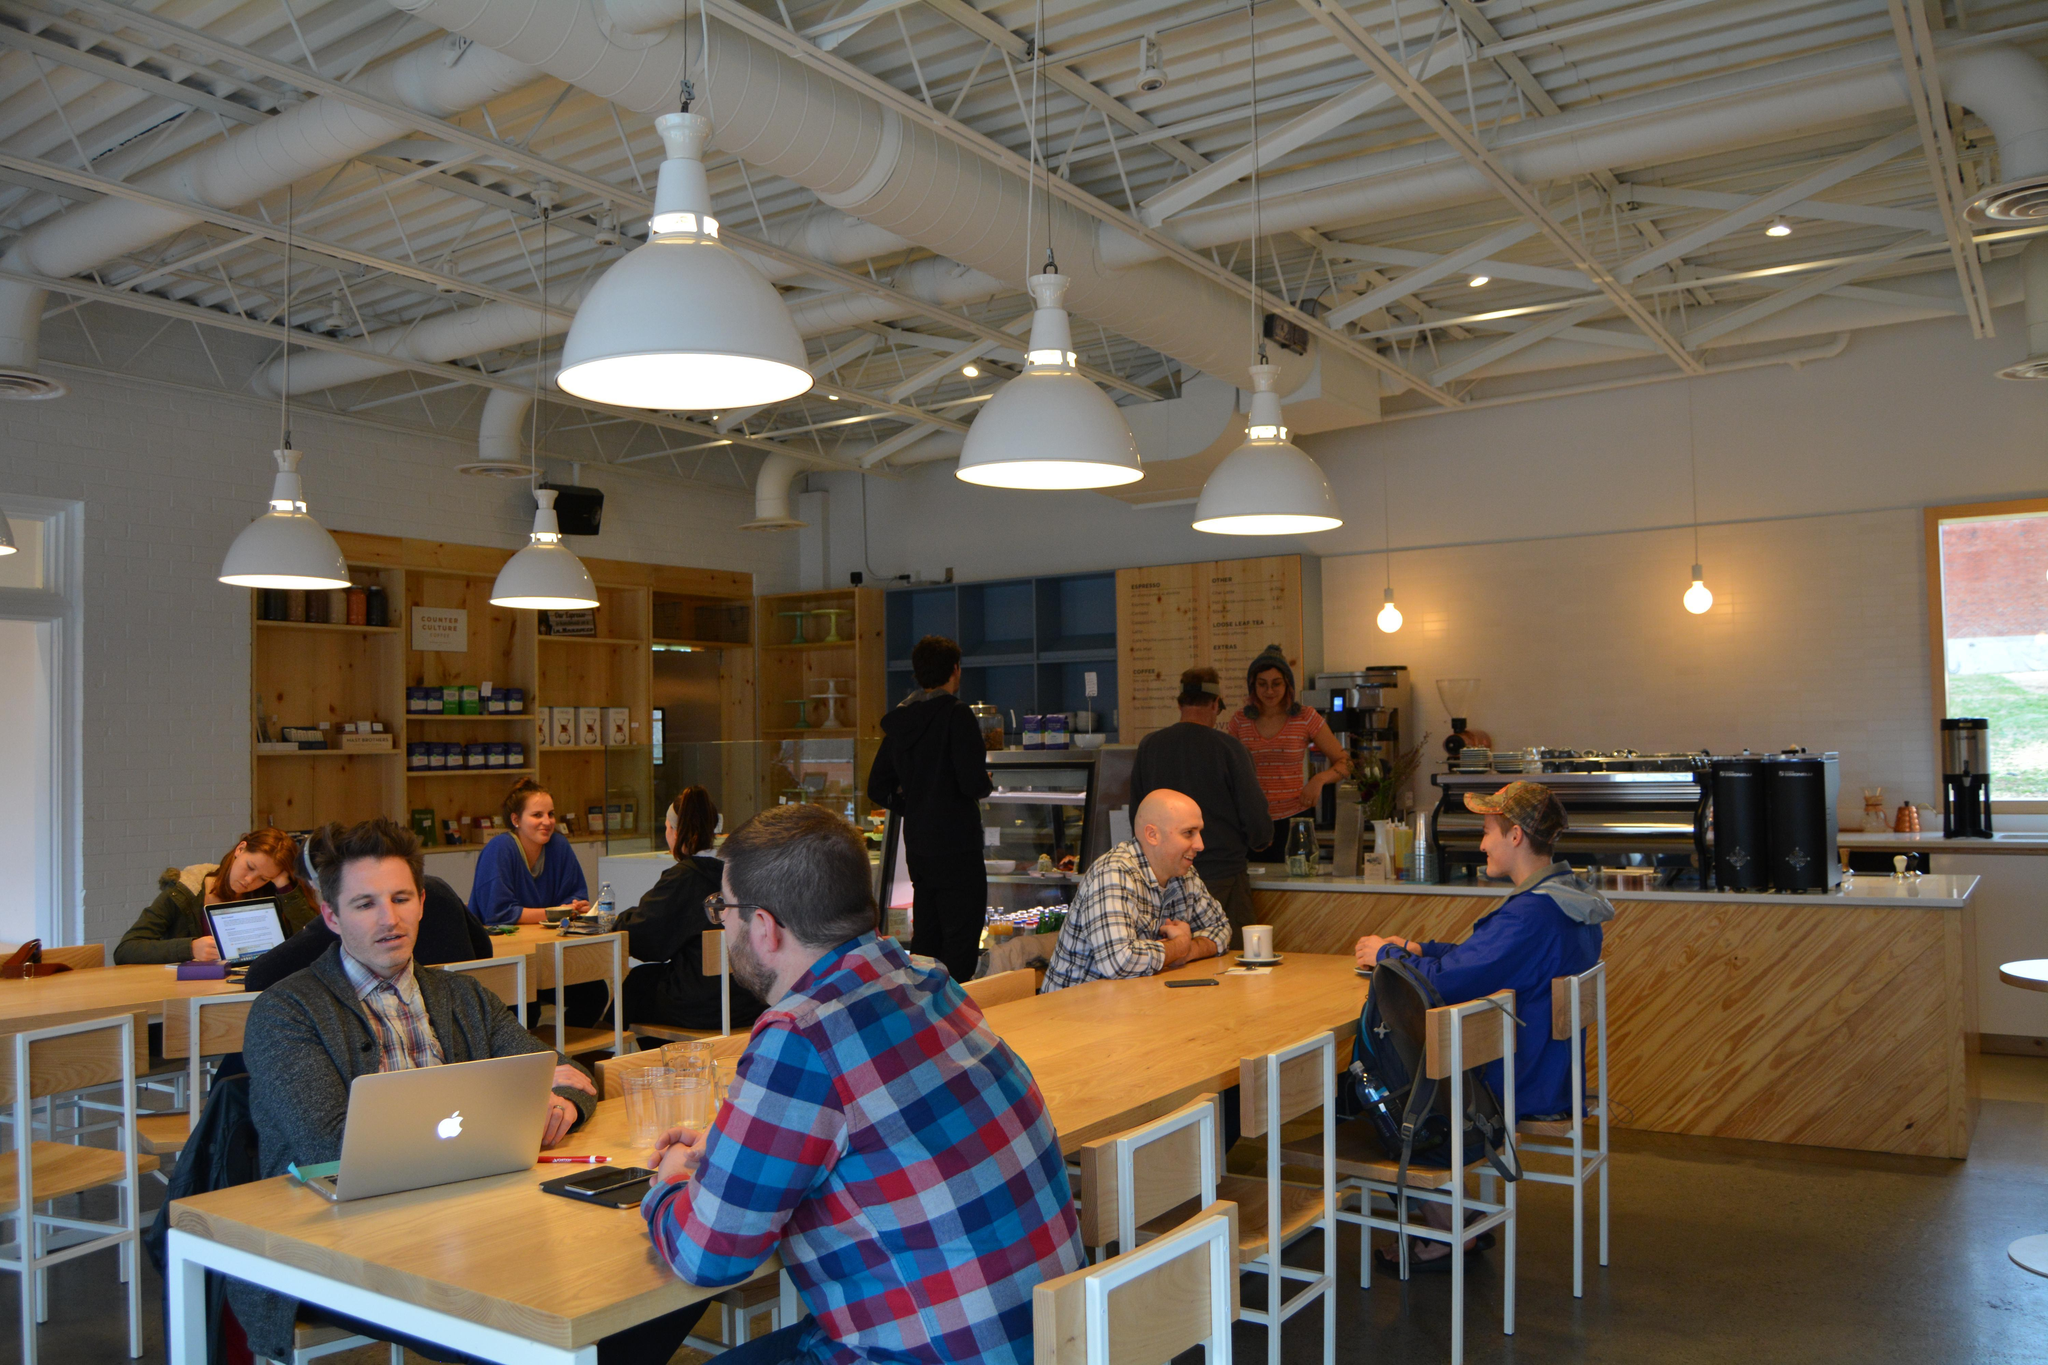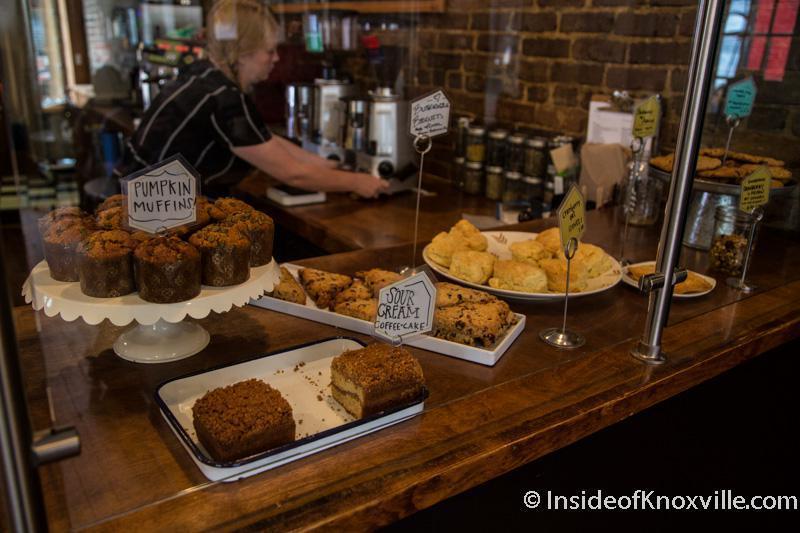The first image is the image on the left, the second image is the image on the right. Assess this claim about the two images: "In at least one image you can see at least 5 adults sitting in  white and light brown chair with at least 5 visible  dropped white lights.". Correct or not? Answer yes or no. Yes. The first image is the image on the left, the second image is the image on the right. For the images displayed, is the sentence "White lamps hang down over tables in a bakery in one of the images." factually correct? Answer yes or no. Yes. 